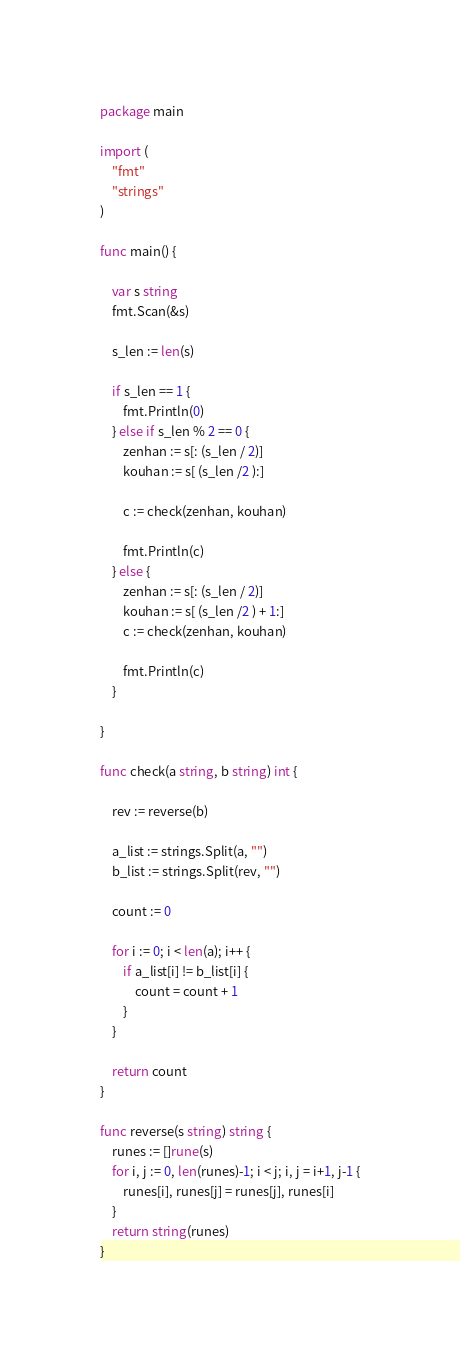<code> <loc_0><loc_0><loc_500><loc_500><_Go_>package main

import (
	"fmt"
	"strings"
)

func main() {

	var s string
	fmt.Scan(&s)

	s_len := len(s)

	if s_len == 1 {
		fmt.Println(0)
	} else if s_len % 2 == 0 {
		zenhan := s[: (s_len / 2)]
		kouhan := s[ (s_len /2 ):]

		c := check(zenhan, kouhan)

		fmt.Println(c)
	} else {
		zenhan := s[: (s_len / 2)]
		kouhan := s[ (s_len /2 ) + 1:]
		c := check(zenhan, kouhan)

		fmt.Println(c)
	}

}

func check(a string, b string) int {

	rev := reverse(b)

	a_list := strings.Split(a, "")
	b_list := strings.Split(rev, "")

	count := 0

	for i := 0; i < len(a); i++ {
		if a_list[i] != b_list[i] {
			count = count + 1
		}
	}

	return count
}

func reverse(s string) string {
	runes := []rune(s)
	for i, j := 0, len(runes)-1; i < j; i, j = i+1, j-1 {
		runes[i], runes[j] = runes[j], runes[i]
	}
	return string(runes)
}
</code> 